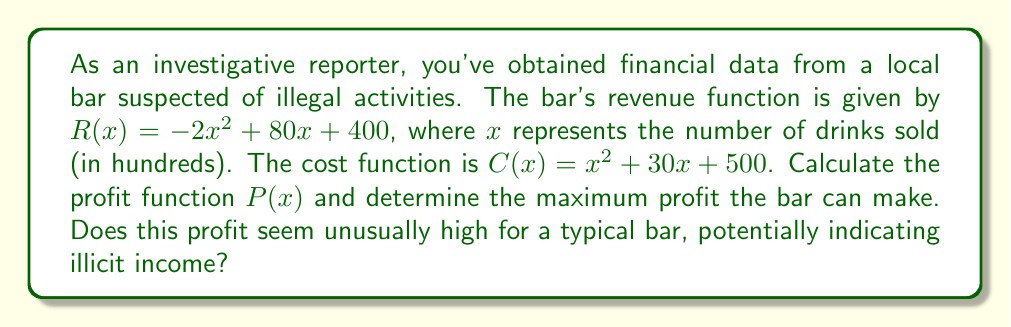Help me with this question. To solve this problem, we'll follow these steps:

1) First, let's recall that the profit function is the difference between revenue and cost:
   
   $P(x) = R(x) - C(x)$

2) We can substitute the given functions:
   
   $P(x) = (-2x^2 + 80x + 400) - (x^2 + 30x + 500)$

3) Simplify by combining like terms:
   
   $P(x) = -2x^2 + 80x + 400 - x^2 - 30x - 500$
   $P(x) = -3x^2 + 50x - 100$

4) To find the maximum profit, we need to find the vertex of this parabola. Since it's a negative parabola (coefficient of $x^2$ is negative), the vertex will represent the maximum point.

5) We can find the x-coordinate of the vertex using the formula $x = -\frac{b}{2a}$, where $a$ and $b$ are the coefficients of $x^2$ and $x$ respectively:

   $x = -\frac{50}{2(-3)} = \frac{25}{3} \approx 8.33$

6) To find the maximum profit, we substitute this x-value back into our profit function:

   $P(\frac{25}{3}) = -3(\frac{25}{3})^2 + 50(\frac{25}{3}) - 100$
   
   $= -3(\frac{625}{9}) + \frac{1250}{3} - 100$
   
   $= -\frac{1875}{9} + \frac{3750}{9} - \frac{900}{9}$
   
   $= \frac{975}{9} \approx 108.33$

7) Therefore, the maximum profit is $\frac{975}{9}$ hundred dollars, or $\$10,833.33$.

This profit seems unusually high for a typical bar selling only about 833 drinks (8.33 hundred), which could indeed indicate potential illicit income or other suspicious activities.
Answer: The profit function is $P(x) = -3x^2 + 50x - 100$, and the maximum profit is $\$10,833.33$. 